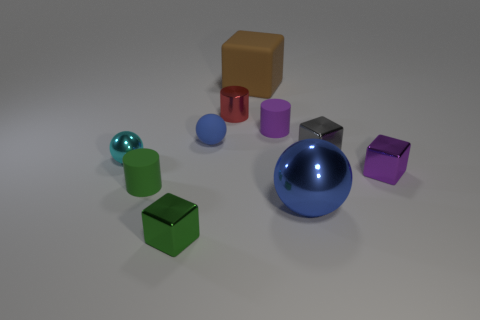How many metallic objects have the same size as the gray metal block?
Provide a succinct answer. 4. What number of objects are blue rubber things or cubes that are to the right of the green shiny cube?
Give a very brief answer. 4. What is the shape of the tiny green rubber object?
Give a very brief answer. Cylinder. Does the tiny metallic cylinder have the same color as the large cube?
Your answer should be very brief. No. What color is the shiny ball that is the same size as the red object?
Give a very brief answer. Cyan. What number of gray objects are small shiny cubes or tiny rubber cylinders?
Give a very brief answer. 1. Are there more metallic balls than cyan shiny things?
Your response must be concise. Yes. There is a cyan shiny ball that is to the left of the red cylinder; is it the same size as the cylinder that is in front of the tiny purple rubber thing?
Offer a very short reply. Yes. There is a matte cylinder that is in front of the purple thing in front of the metallic sphere on the left side of the big matte block; what is its color?
Provide a short and direct response. Green. Are there any tiny red metallic objects of the same shape as the purple metallic object?
Make the answer very short. No. 